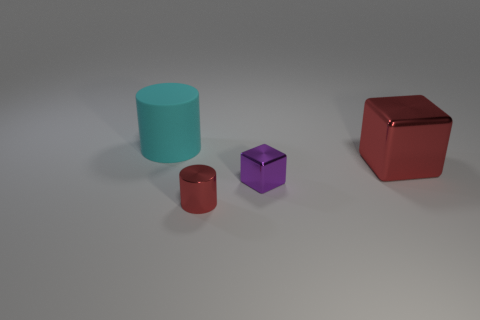Add 2 small red things. How many objects exist? 6 Subtract 1 cylinders. How many cylinders are left? 1 Subtract all cyan cylinders. How many cylinders are left? 1 Add 1 large cyan cylinders. How many large cyan cylinders are left? 2 Add 4 small blue metallic cubes. How many small blue metallic cubes exist? 4 Subtract 0 blue cylinders. How many objects are left? 4 Subtract all brown blocks. Subtract all blue spheres. How many blocks are left? 2 Subtract all small metal cubes. Subtract all cyan matte things. How many objects are left? 2 